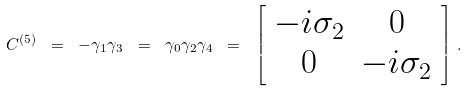<formula> <loc_0><loc_0><loc_500><loc_500>C ^ { ( 5 ) } \ = \ - \gamma _ { 1 } \gamma _ { 3 } \ = \ \gamma _ { 0 } \gamma _ { 2 } \gamma _ { 4 } \ = \ \left [ \begin{array} { c c } - i \sigma _ { 2 } & 0 \\ 0 & - i \sigma _ { 2 } \end{array} \right ] \, .</formula> 